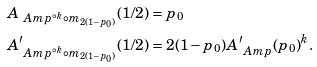<formula> <loc_0><loc_0><loc_500><loc_500>& A _ { \ A m p ^ { \circ k } \circ m _ { 2 ( 1 - p _ { 0 } ) } } ( 1 / 2 ) = p _ { 0 } \\ & A _ { \ A m p ^ { \circ k } \circ m _ { 2 ( 1 - p _ { 0 } ) } } ^ { \prime } ( 1 / 2 ) = 2 ( 1 - p _ { 0 } ) A _ { \ A m p } ^ { \prime } ( p _ { 0 } ) ^ { k } .</formula> 